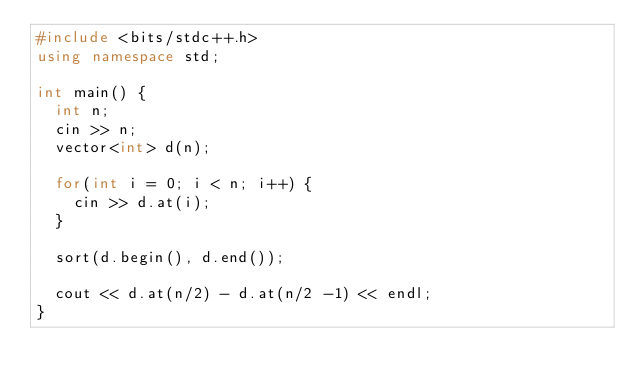Convert code to text. <code><loc_0><loc_0><loc_500><loc_500><_C++_>#include <bits/stdc++.h>
using namespace std;

int main() {
  int n;
  cin >> n;
  vector<int> d(n);
  
  for(int i = 0; i < n; i++) {
  	cin >> d.at(i);
  }
  
  sort(d.begin(), d.end());
  
  cout << d.at(n/2) - d.at(n/2 -1) << endl;
}
</code> 